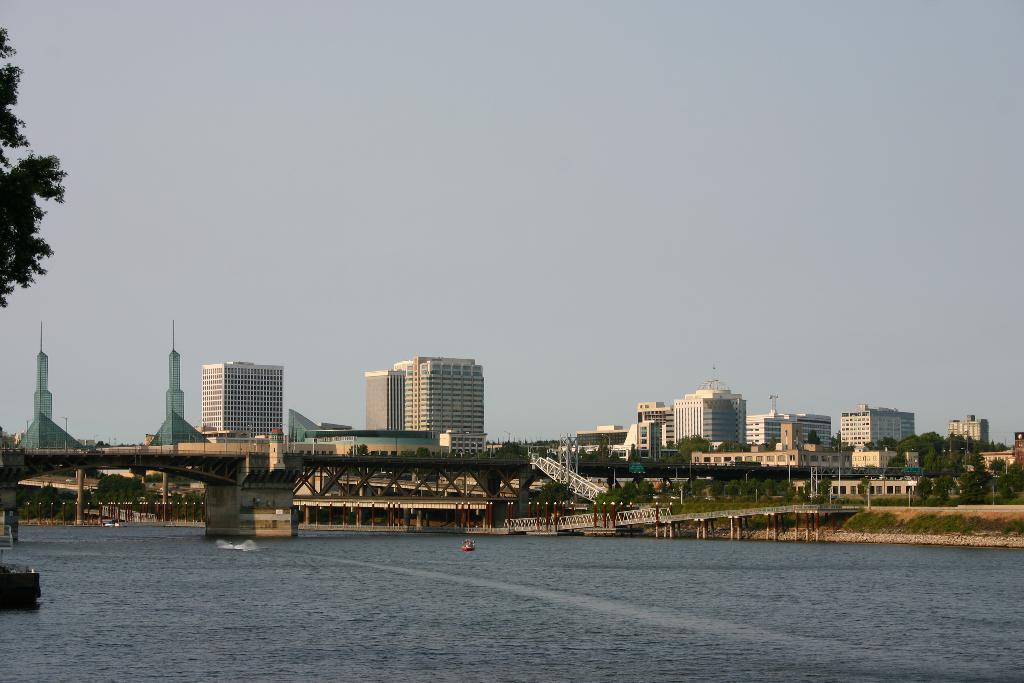What is the primary element in the image? There is water in the image. What can be seen in the water? There are boats in the water. What type of vegetation is present in the image? There are trees in the image. What structures are visible in the image? There are buildings in the image. What is visible in the background of the image? The sky is visible in the image. What type of apple is being used as a guide for the boats in the image? There is no apple present in the image, nor is there any indication that an apple is being used as a guide for the boats. 